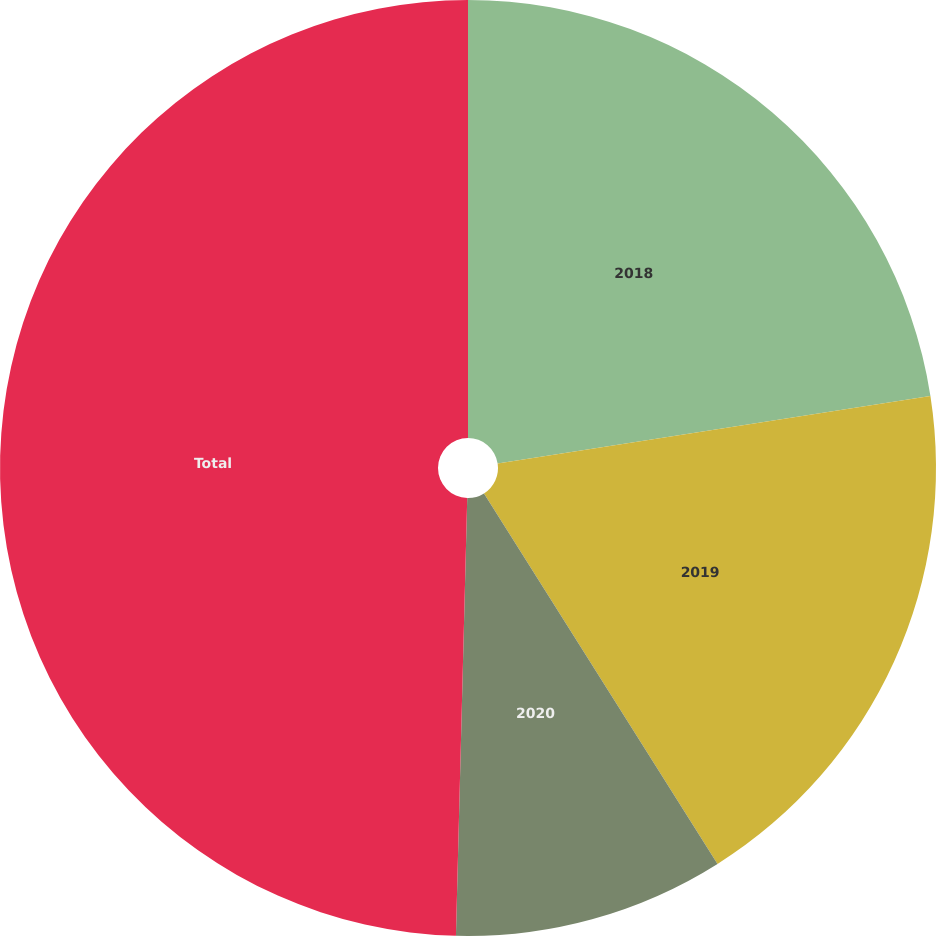<chart> <loc_0><loc_0><loc_500><loc_500><pie_chart><fcel>2018<fcel>2019<fcel>2020<fcel>Total<nl><fcel>22.54%<fcel>18.51%<fcel>9.36%<fcel>49.59%<nl></chart> 